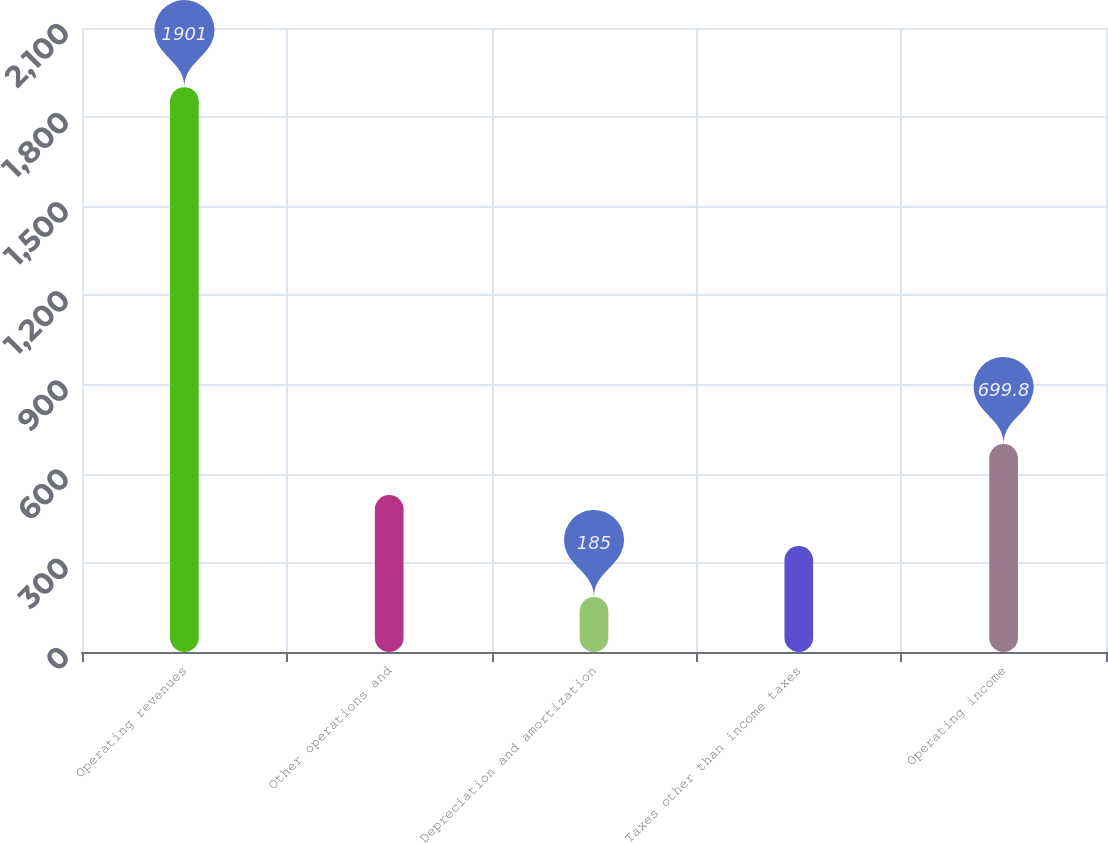<chart> <loc_0><loc_0><loc_500><loc_500><bar_chart><fcel>Operating revenues<fcel>Other operations and<fcel>Depreciation and amortization<fcel>Taxes other than income taxes<fcel>Operating income<nl><fcel>1901<fcel>528.2<fcel>185<fcel>356.6<fcel>699.8<nl></chart> 